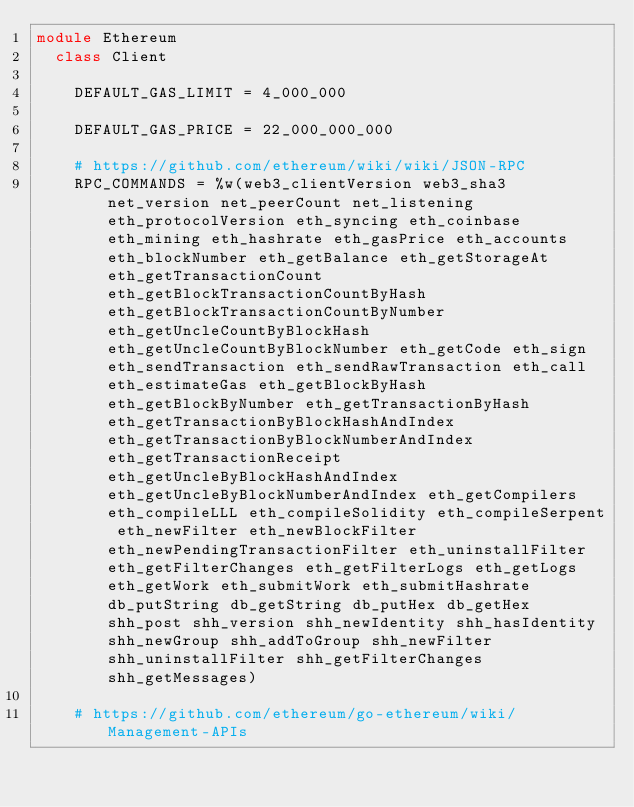<code> <loc_0><loc_0><loc_500><loc_500><_Ruby_>module Ethereum
  class Client

    DEFAULT_GAS_LIMIT = 4_000_000

    DEFAULT_GAS_PRICE = 22_000_000_000

    # https://github.com/ethereum/wiki/wiki/JSON-RPC
    RPC_COMMANDS = %w(web3_clientVersion web3_sha3 net_version net_peerCount net_listening eth_protocolVersion eth_syncing eth_coinbase eth_mining eth_hashrate eth_gasPrice eth_accounts eth_blockNumber eth_getBalance eth_getStorageAt eth_getTransactionCount eth_getBlockTransactionCountByHash eth_getBlockTransactionCountByNumber eth_getUncleCountByBlockHash eth_getUncleCountByBlockNumber eth_getCode eth_sign eth_sendTransaction eth_sendRawTransaction eth_call eth_estimateGas eth_getBlockByHash eth_getBlockByNumber eth_getTransactionByHash eth_getTransactionByBlockHashAndIndex eth_getTransactionByBlockNumberAndIndex eth_getTransactionReceipt eth_getUncleByBlockHashAndIndex eth_getUncleByBlockNumberAndIndex eth_getCompilers eth_compileLLL eth_compileSolidity eth_compileSerpent eth_newFilter eth_newBlockFilter eth_newPendingTransactionFilter eth_uninstallFilter eth_getFilterChanges eth_getFilterLogs eth_getLogs eth_getWork eth_submitWork eth_submitHashrate db_putString db_getString db_putHex db_getHex shh_post shh_version shh_newIdentity shh_hasIdentity shh_newGroup shh_addToGroup shh_newFilter shh_uninstallFilter shh_getFilterChanges shh_getMessages)

    # https://github.com/ethereum/go-ethereum/wiki/Management-APIs</code> 